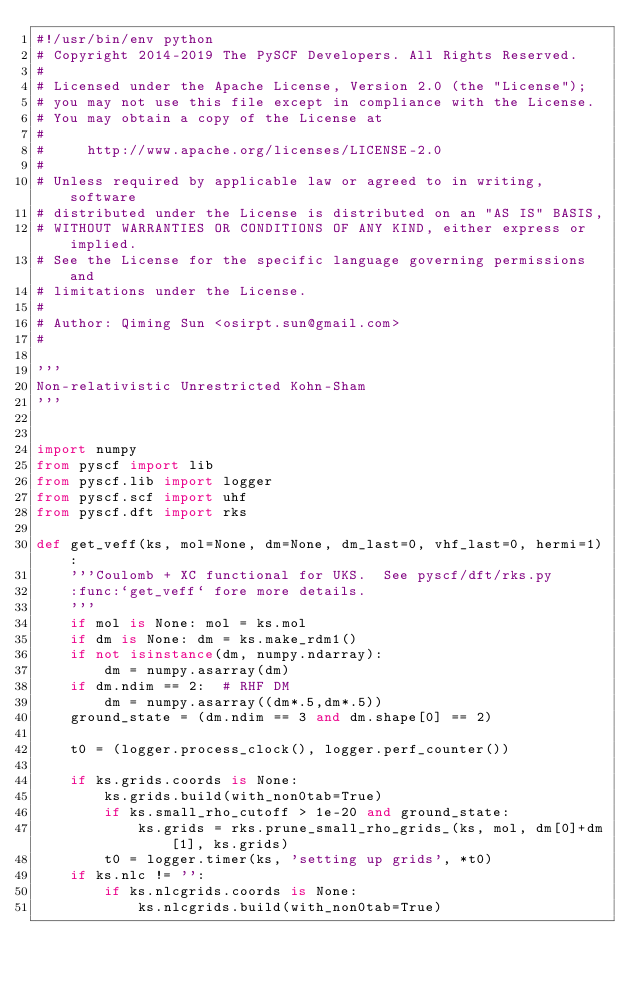Convert code to text. <code><loc_0><loc_0><loc_500><loc_500><_Python_>#!/usr/bin/env python
# Copyright 2014-2019 The PySCF Developers. All Rights Reserved.
#
# Licensed under the Apache License, Version 2.0 (the "License");
# you may not use this file except in compliance with the License.
# You may obtain a copy of the License at
#
#     http://www.apache.org/licenses/LICENSE-2.0
#
# Unless required by applicable law or agreed to in writing, software
# distributed under the License is distributed on an "AS IS" BASIS,
# WITHOUT WARRANTIES OR CONDITIONS OF ANY KIND, either express or implied.
# See the License for the specific language governing permissions and
# limitations under the License.
#
# Author: Qiming Sun <osirpt.sun@gmail.com>
#

'''
Non-relativistic Unrestricted Kohn-Sham
'''


import numpy
from pyscf import lib
from pyscf.lib import logger
from pyscf.scf import uhf
from pyscf.dft import rks

def get_veff(ks, mol=None, dm=None, dm_last=0, vhf_last=0, hermi=1):
    '''Coulomb + XC functional for UKS.  See pyscf/dft/rks.py
    :func:`get_veff` fore more details.
    '''
    if mol is None: mol = ks.mol
    if dm is None: dm = ks.make_rdm1()
    if not isinstance(dm, numpy.ndarray):
        dm = numpy.asarray(dm)
    if dm.ndim == 2:  # RHF DM
        dm = numpy.asarray((dm*.5,dm*.5))
    ground_state = (dm.ndim == 3 and dm.shape[0] == 2)

    t0 = (logger.process_clock(), logger.perf_counter())

    if ks.grids.coords is None:
        ks.grids.build(with_non0tab=True)
        if ks.small_rho_cutoff > 1e-20 and ground_state:
            ks.grids = rks.prune_small_rho_grids_(ks, mol, dm[0]+dm[1], ks.grids)
        t0 = logger.timer(ks, 'setting up grids', *t0)
    if ks.nlc != '':
        if ks.nlcgrids.coords is None:
            ks.nlcgrids.build(with_non0tab=True)</code> 